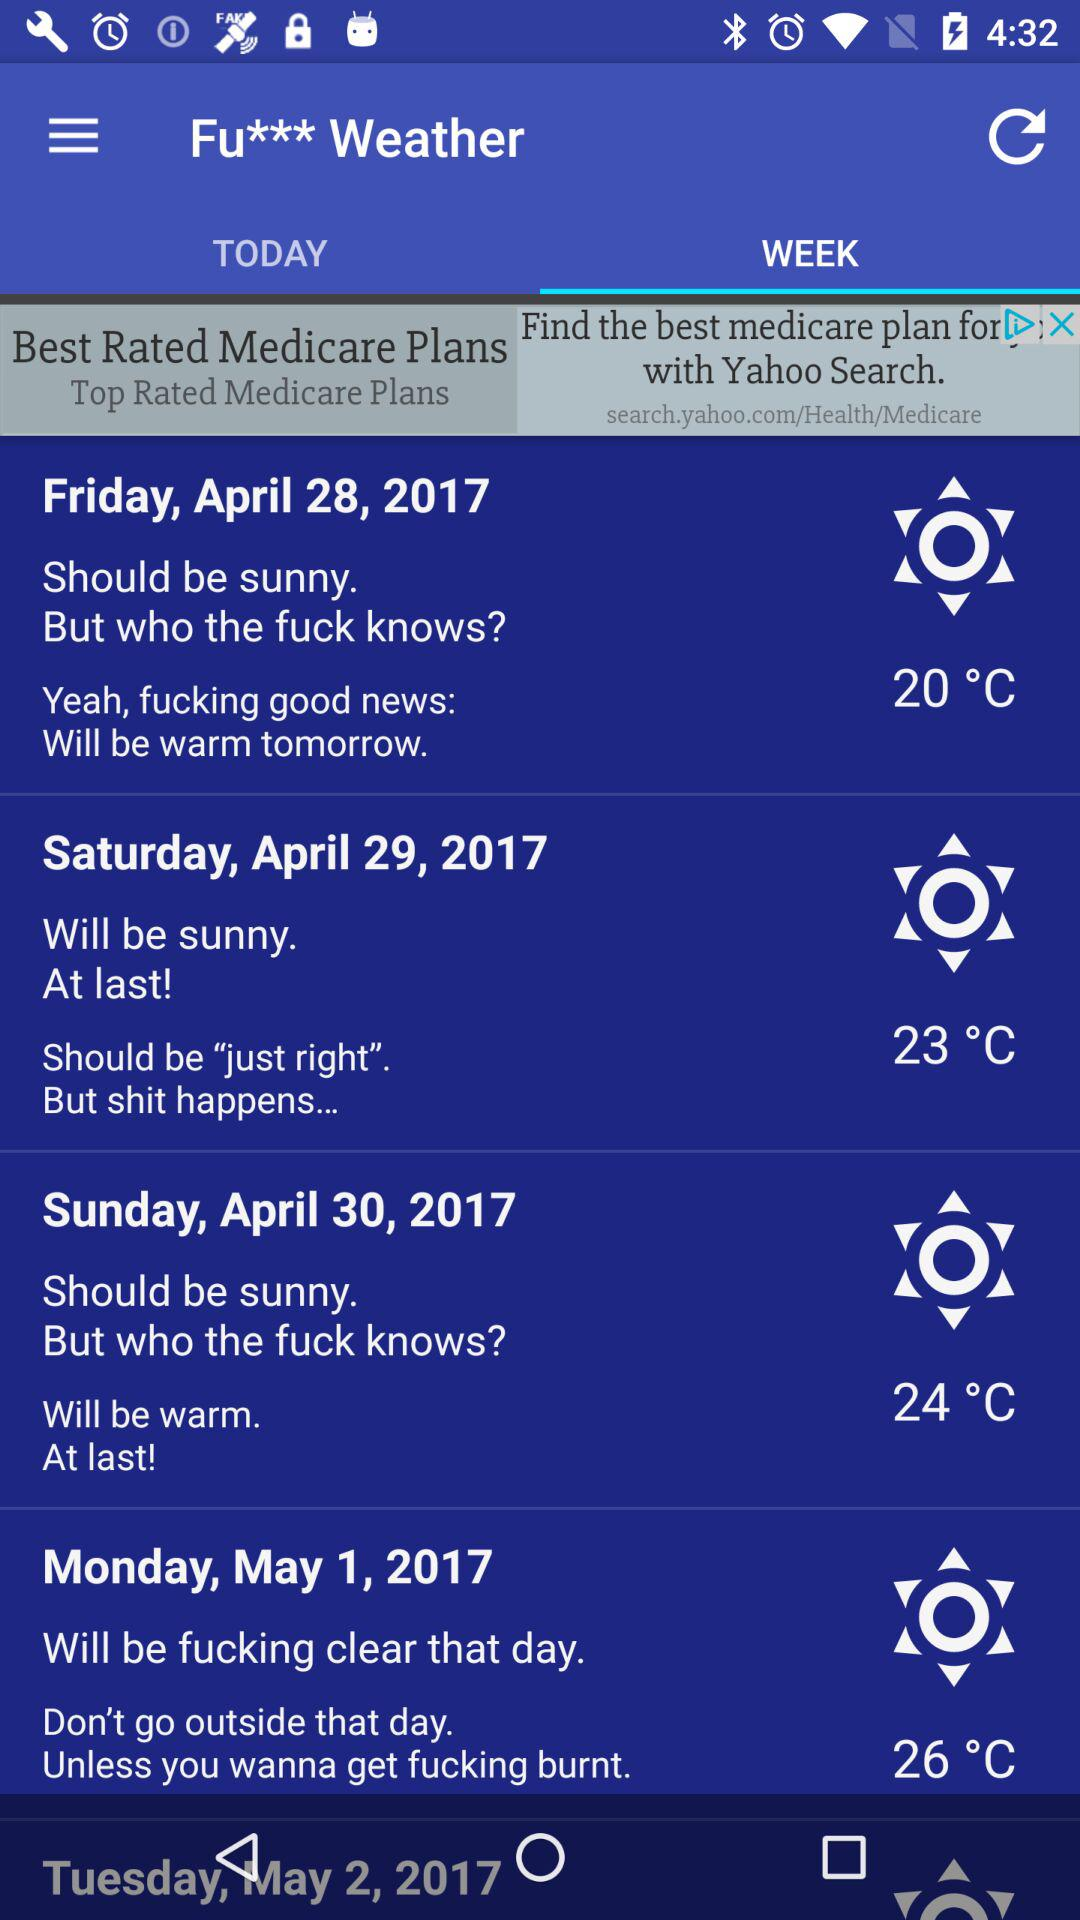What is the highest temperature in the forecast?
Answer the question using a single word or phrase. 26°C 